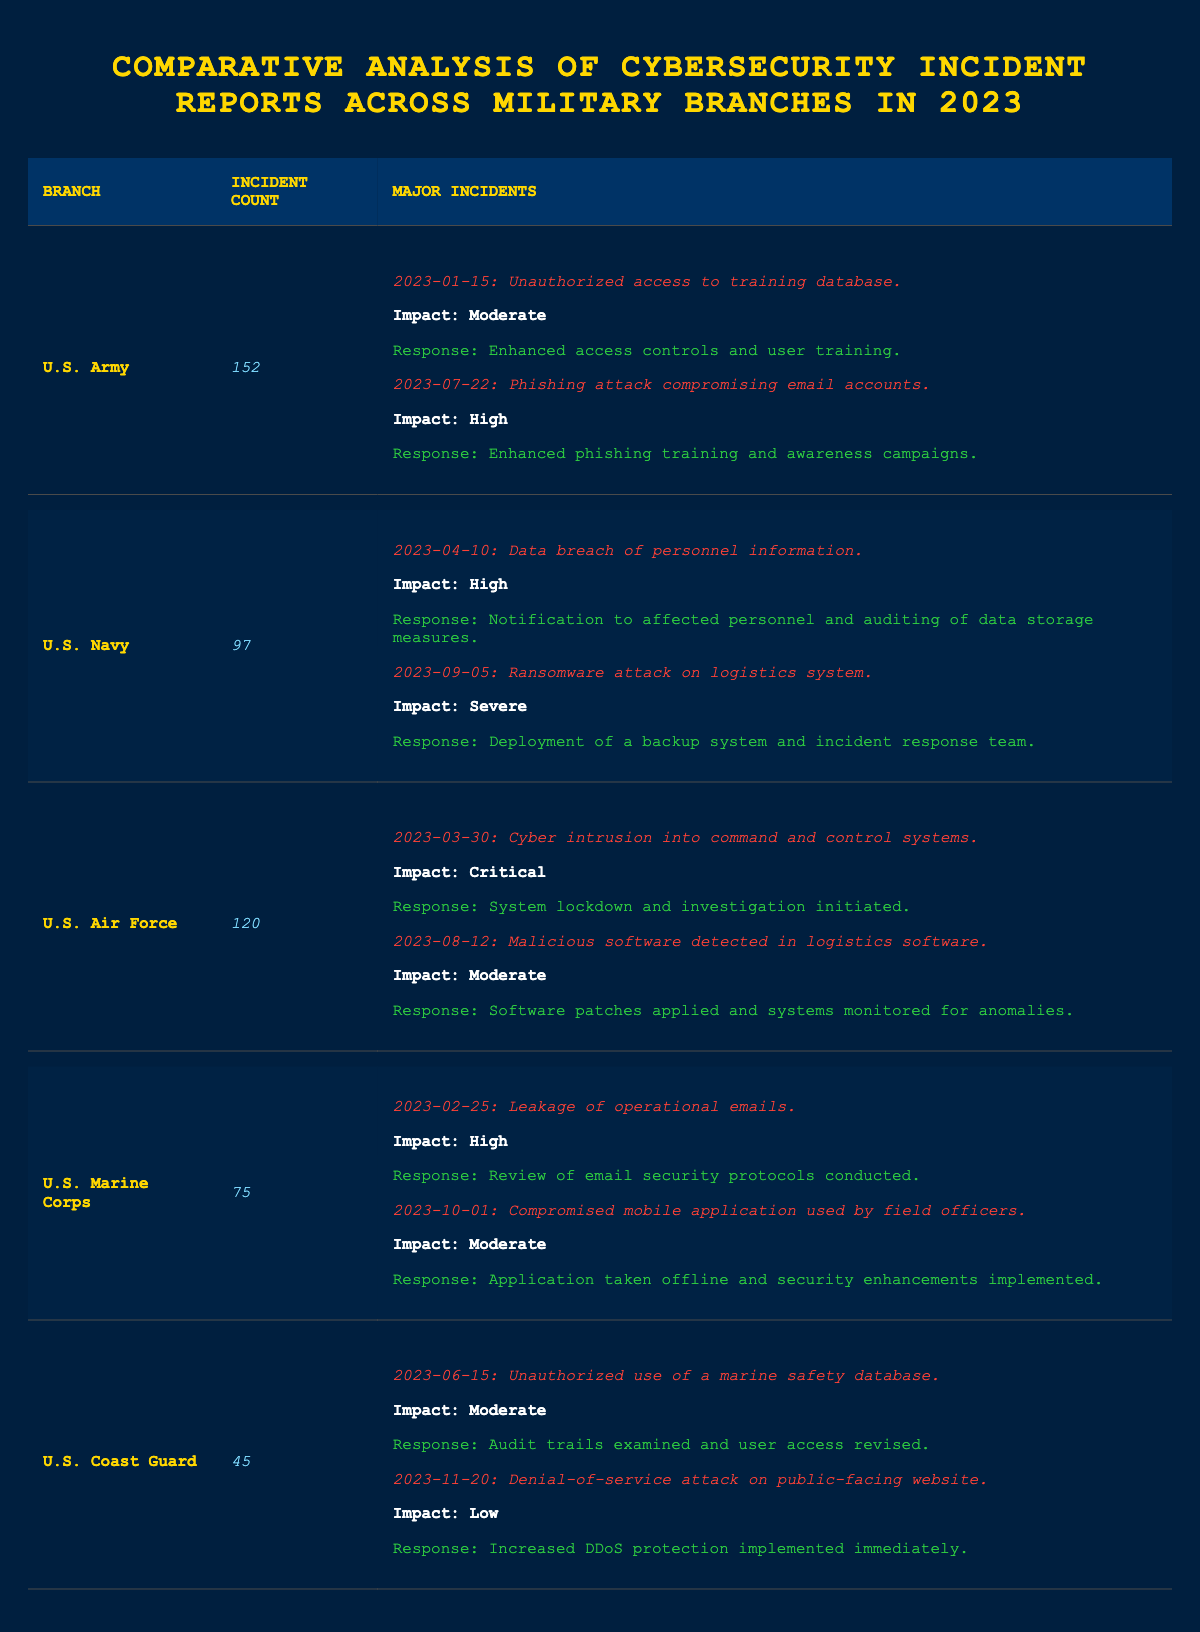What is the total incident count across all military branches? To find the total incident count, sum the incident counts for each branch: 152 (Army) + 97 (Navy) + 120 (Air Force) + 75 (Marine Corps) + 45 (Coast Guard) = 489.
Answer: 489 Which branch reported the highest number of cybersecurity incidents? By examining the incident counts for each branch, U.S. Army has the highest count at 152 incidents.
Answer: U.S. Army What is the average number of incidents reported by each branch? The total incident count is 489 and there are 5 branches. Therefore, the average is 489/5 = 97.8, which can be rounded to 98.
Answer: 98 Did the U.S. Coast Guard report any major incidents with a severity of "Severe"? A review of the major incidents for U.S. Coast Guard indicates that the highest severity reported is "Moderate" and "Low," confirming no incidents of "Severe."
Answer: No How many major incidents did the U.S. Navy report? The U.S. Navy has listed 2 major incidents in the table, confirming this number through a quick review of the entries.
Answer: 2 What is the percentage of incidents categorized as "Critical" among all reported incidents? There is 1 "Critical" incident (Air Force) out of a total of 489 incidents. The percentage is (1/489) * 100 = 0.2%.
Answer: 0.2% Which branch had the least number of incidents and what was the count? The U.S. Coast Guard has the least number of incidents with a count of 45, which is verified by comparing all incident counts in the table.
Answer: U.S. Coast Guard with 45 What incident from the U.S. Army has the highest impact level? Within U.S. Army incidents, the one on 2023-07-22 is labeled "High," which is the highest impact level noted for their incidents this year, checking confirms no "Critical" incidents were recorded.
Answer: Phishing attack compromising email accounts on 2023-07-22 How many major incidents did the U.S. Marine Corps report and what was the highest impact level? The U.S. Marine Corps reported 2 major incidents, among which the highest impact level is "High," which is found by reviewing the specific impacts of each incident.
Answer: 2 major incidents with the highest impact of "High" What impact level did the major incidents from the U.S. Air Force generally have? U.S. Air Force had one "Critical" and one "Moderate" major incident, suggesting a range of impacted outcomes from severe to moderate based on examination.
Answer: Critical and Moderate 